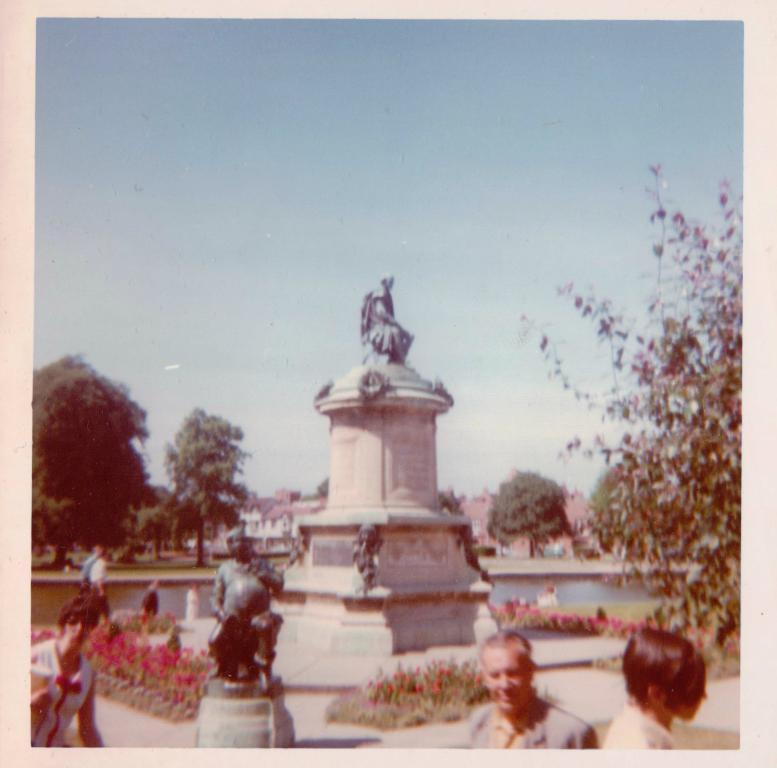What is depicted in the photocopy in the image? There is a photocopy of people in the image. What type of natural vegetation can be seen in the image? There are trees in the image. What type of man-made structures are present in the image? There are statues and houses in the image. What type of landscape feature is visible in the image? There is water visible in the image. What part of the natural environment is visible in the image? The sky is visible in the image. What type of rake is being used to clean up the aftermath of the event in the image? There is no event or rake present in the image; it features a photocopy of people, trees, statues, houses, water, and the sky. 